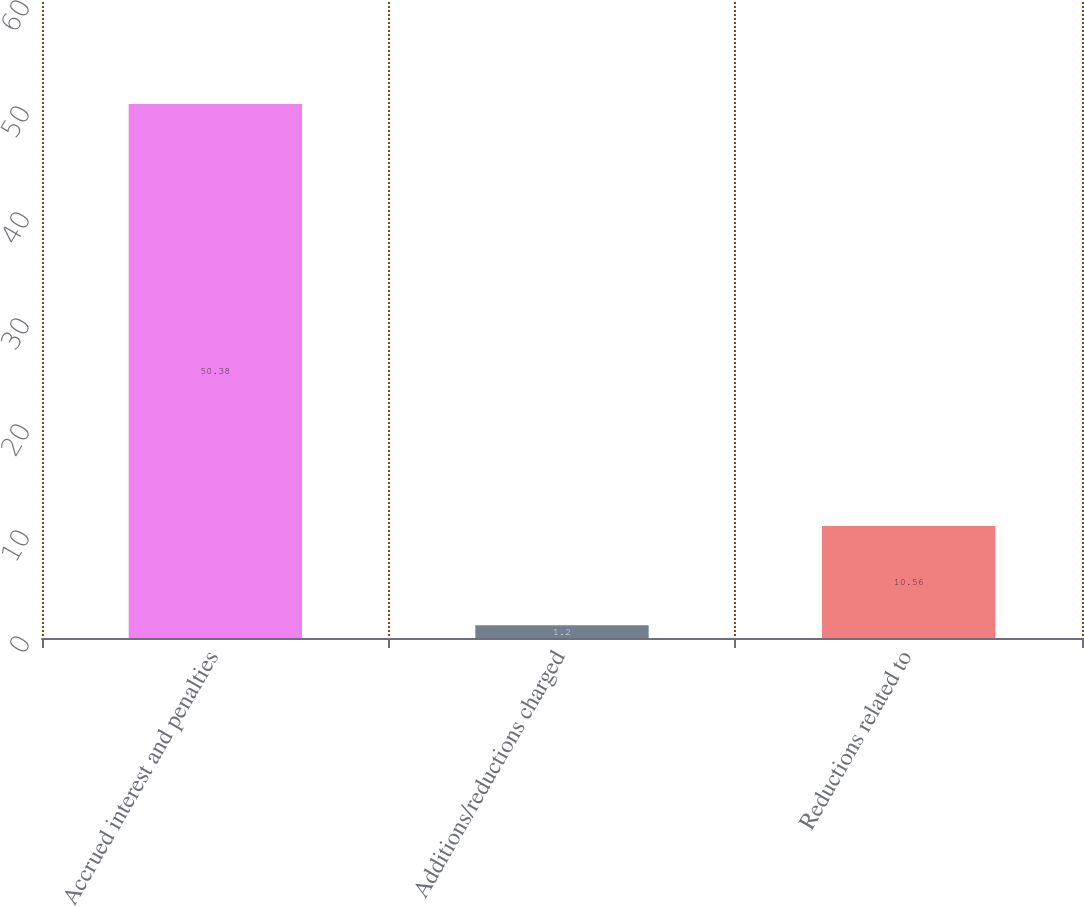Convert chart. <chart><loc_0><loc_0><loc_500><loc_500><bar_chart><fcel>Accrued interest and penalties<fcel>Additions/reductions charged<fcel>Reductions related to<nl><fcel>50.38<fcel>1.2<fcel>10.56<nl></chart> 